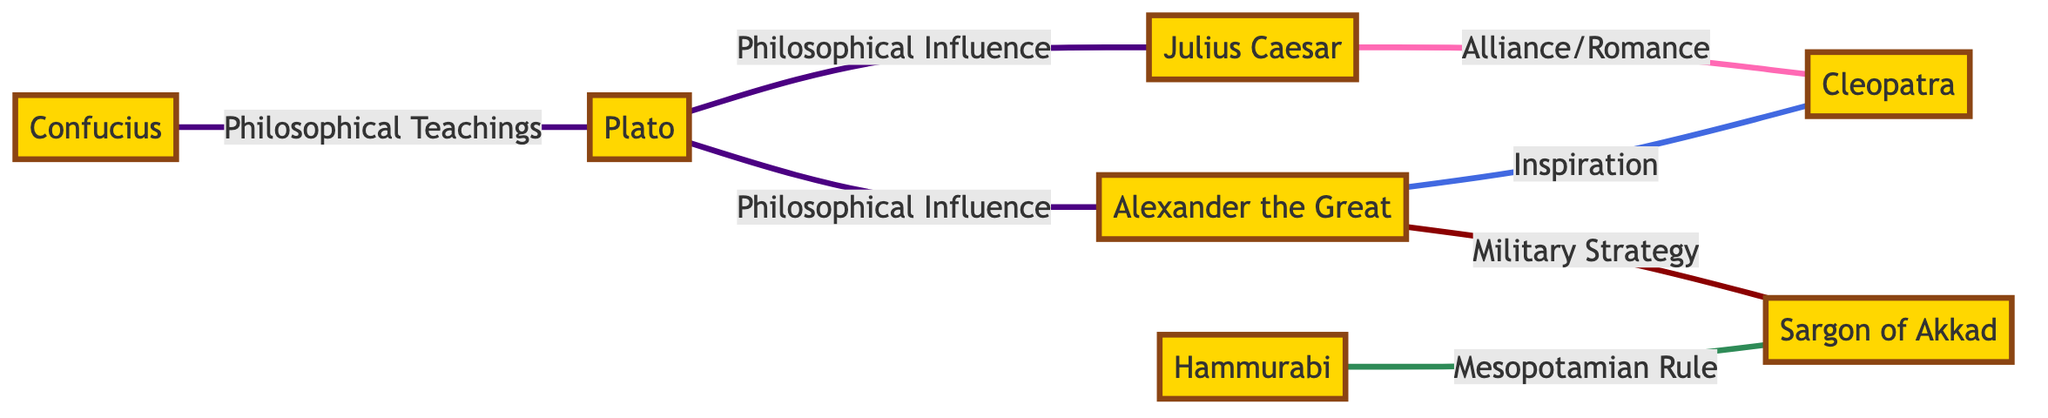What is the total number of nodes in the diagram? The diagram lists seven unique figures: Julius Caesar, Cleopatra, Alexander the Great, Hammurabi, Sargon of Akkad, Plato, and Confucius. Counting these gives a total of seven nodes.
Answer: 7 How many edges are connecting Aristotle to other figures? The diagram displays one edge connected to Aristotle, connecting him solely to Alexander the Great. Thus, Aristotle has one direct connection in this diagram.
Answer: 1 What is the relationship between Julius Caesar and Cleopatra? The diagram indicates an edge labeled "Alliance/Romance" connecting Julius Caesar and Cleopatra. This suggests a personal or political alliance.
Answer: Alliance/Romance Which ancient figure is noted for military strategy that impacted Alexander the Great? The edge labeled "Military Strategy" connects Sargon of Akkad to Alexander the Great, indicating that Sargon influenced Alexander's military tactics.
Answer: Sargon of Akkad What philosophical influence did Plato have on Julius Caesar? The diagram shows an edge labeled "Philosophical Influence" connecting Plato to Julius Caesar. This suggests that Plato's teachings influenced Caesar in some way.
Answer: Philosophical Influence Which two figures are linked by philosophical teachings? The edge connecting Confucius and Plato is labeled "Philosophical Teachings," indicating a direct philosophical relationship between these two figures.
Answer: Confucius and Plato What type of relationship does Alexander the Great have with Cleopatra? The connection between Alexander the Great and Cleopatra is marked as "Inspiration," indicating that Alexander inspired Cleopatra in various ways, possibly politically or culturally.
Answer: Inspiration How does Hammurabi relate to Sargon of Akkad? The edge drawn between Hammurabi and Sargon of Akkad is labeled "Mesopotamian Rule," suggesting a connection in governance or legal systems across their regions.
Answer: Mesopotamian Rule Which figure is connected to the most other figures and how many connections do they have? Plato has three connections: to Alexander the Great, Julius Caesar, and Confucius. Therefore, he is connected to the most figures in the diagram with three edges.
Answer: Plato, 3 